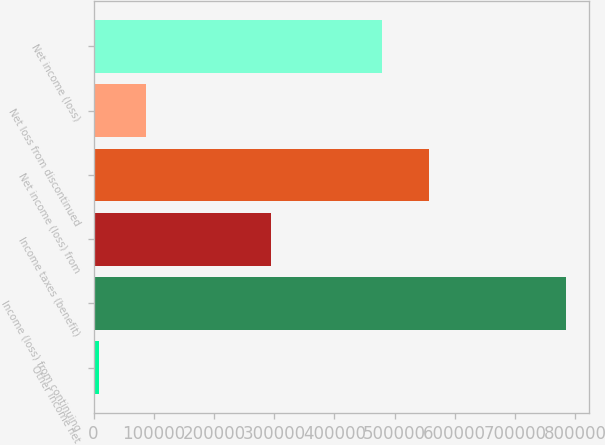<chart> <loc_0><loc_0><loc_500><loc_500><bar_chart><fcel>Other income net<fcel>Income (loss) from continuing<fcel>Income taxes (benefit)<fcel>Net income (loss) from<fcel>Net loss from discontinued<fcel>Net income (loss)<nl><fcel>9298<fcel>784135<fcel>295189<fcel>556726<fcel>86781.7<fcel>479242<nl></chart> 